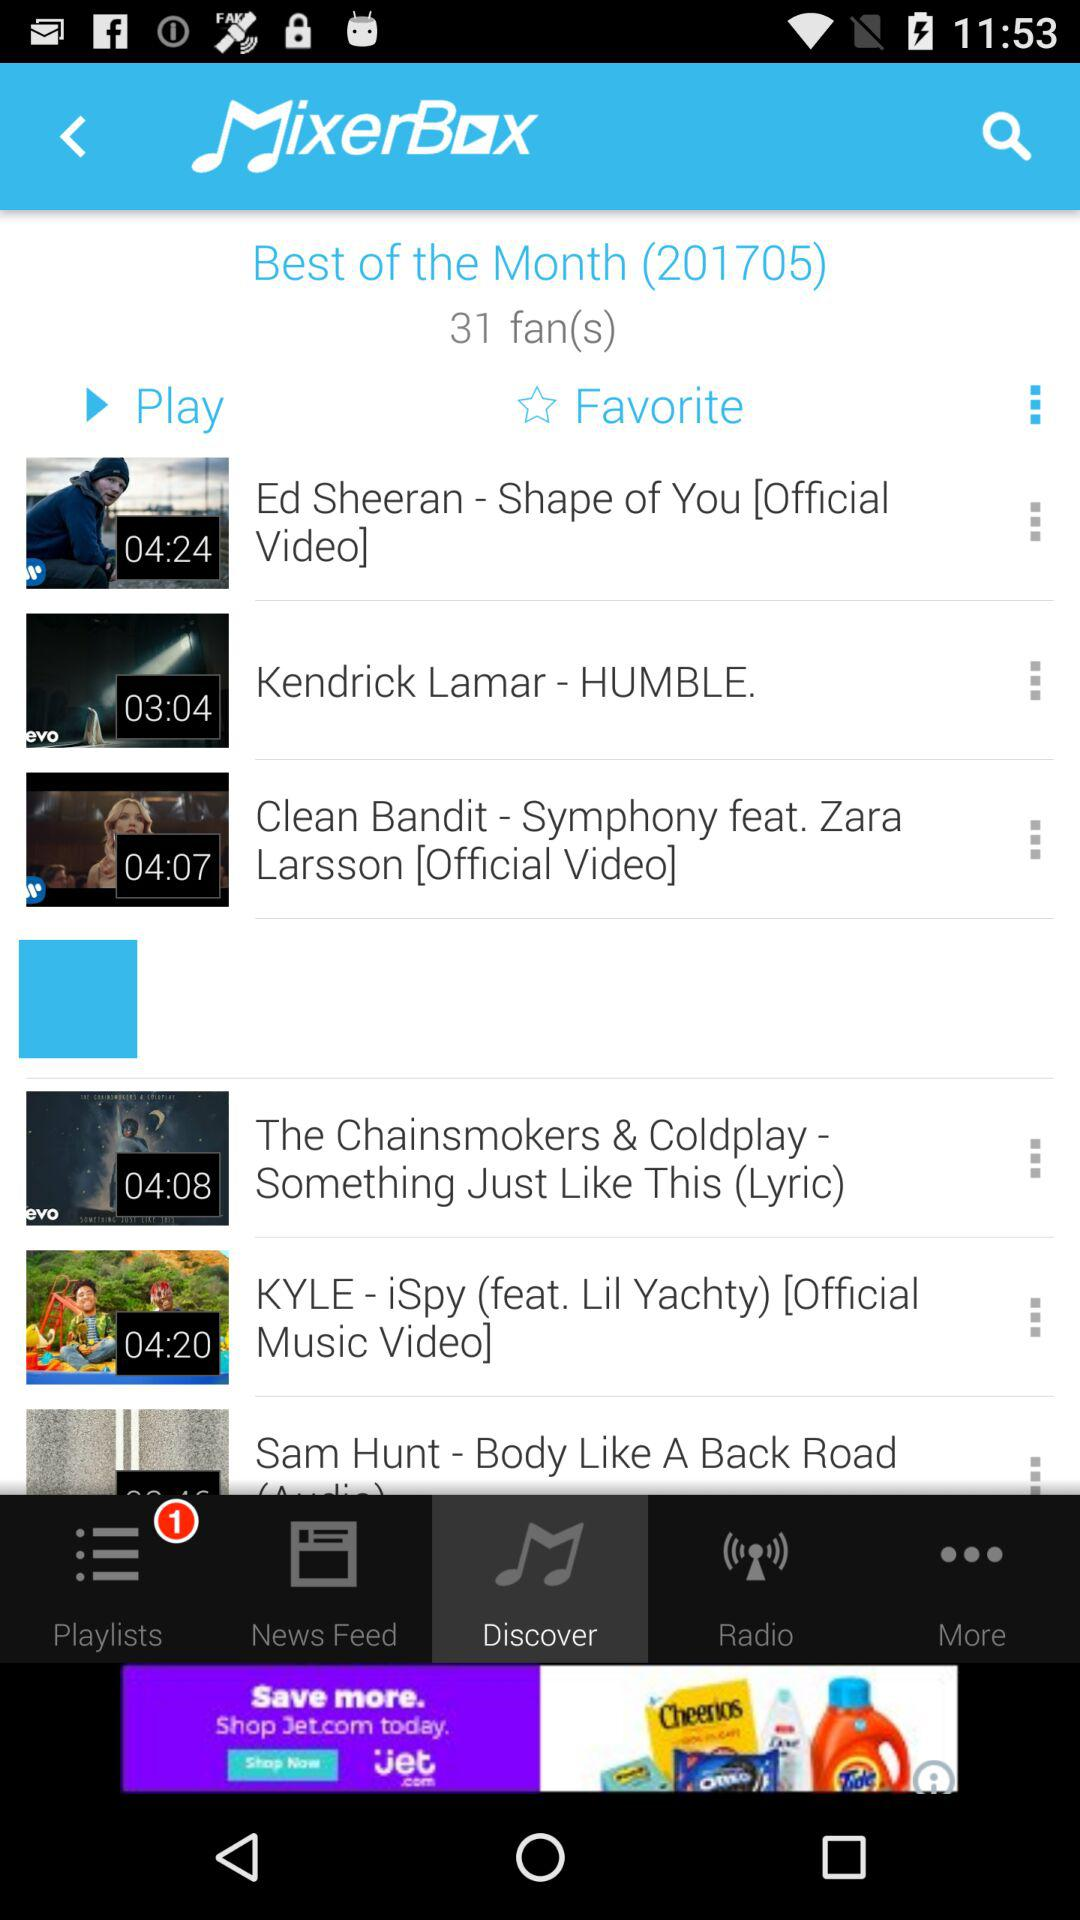What is the singer name of the "HUMBLE." song? The singer name is Kendrick Lamar. 